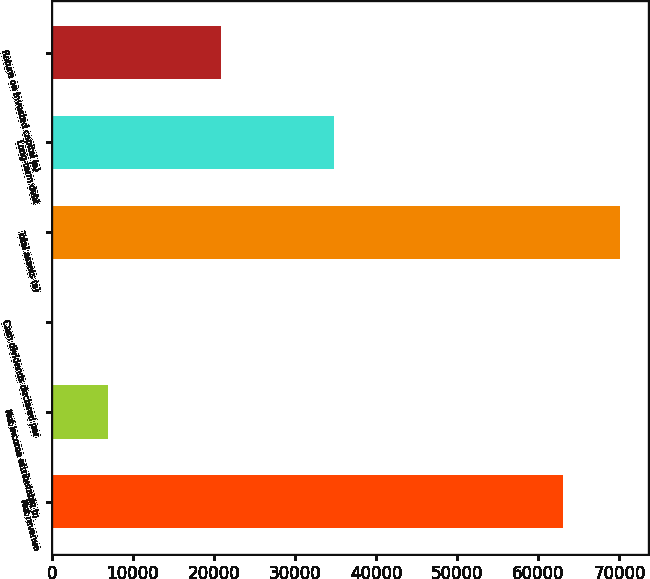Convert chart. <chart><loc_0><loc_0><loc_500><loc_500><bar_chart><fcel>Net revenue<fcel>Net income attributable to<fcel>Cash dividends declared per<fcel>Total assets (a)<fcel>Long-term debt<fcel>Return on invested capital (a)<nl><fcel>63056<fcel>6969.18<fcel>2.76<fcel>70022.4<fcel>34834.9<fcel>20902<nl></chart> 